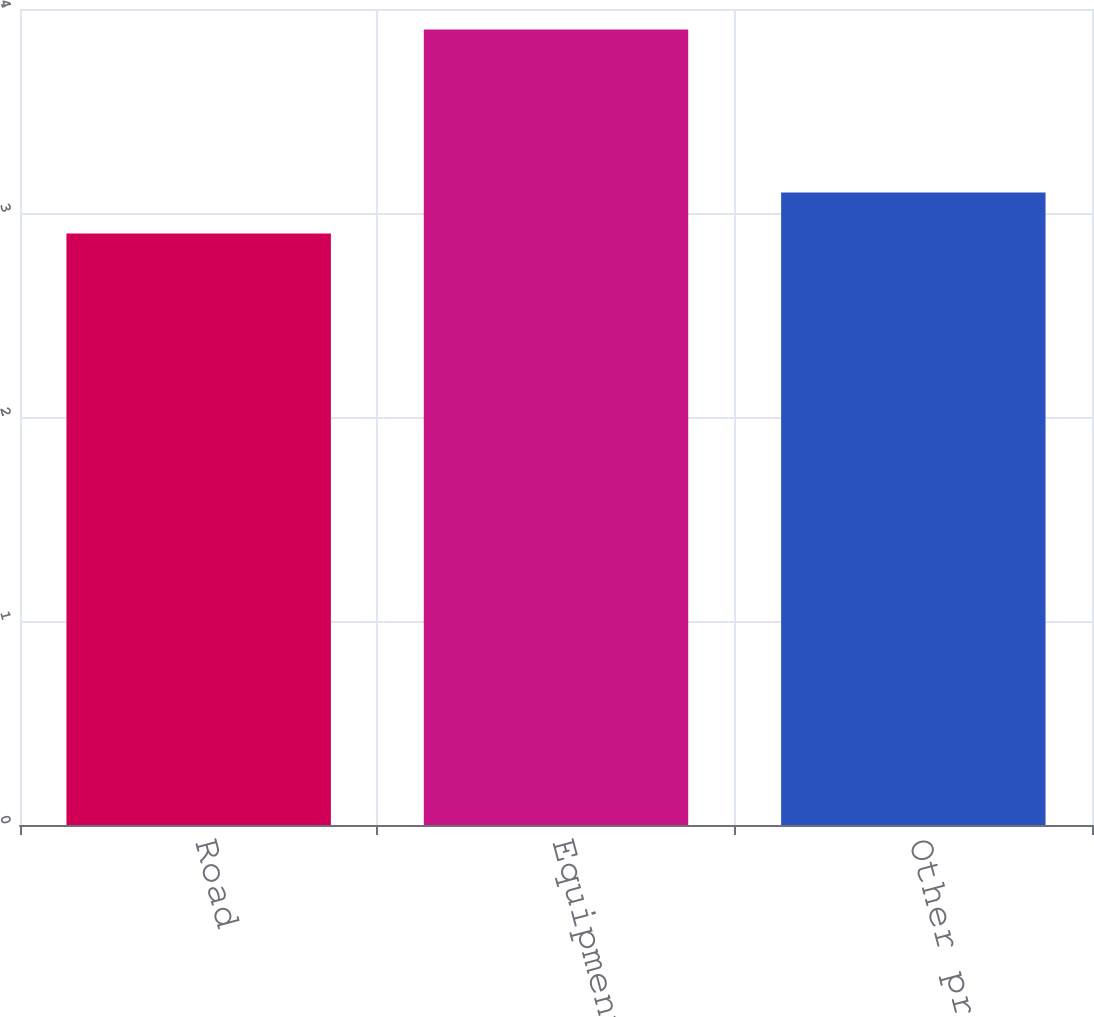Convert chart. <chart><loc_0><loc_0><loc_500><loc_500><bar_chart><fcel>Road<fcel>Equipment<fcel>Other property<nl><fcel>2.9<fcel>3.9<fcel>3.1<nl></chart> 